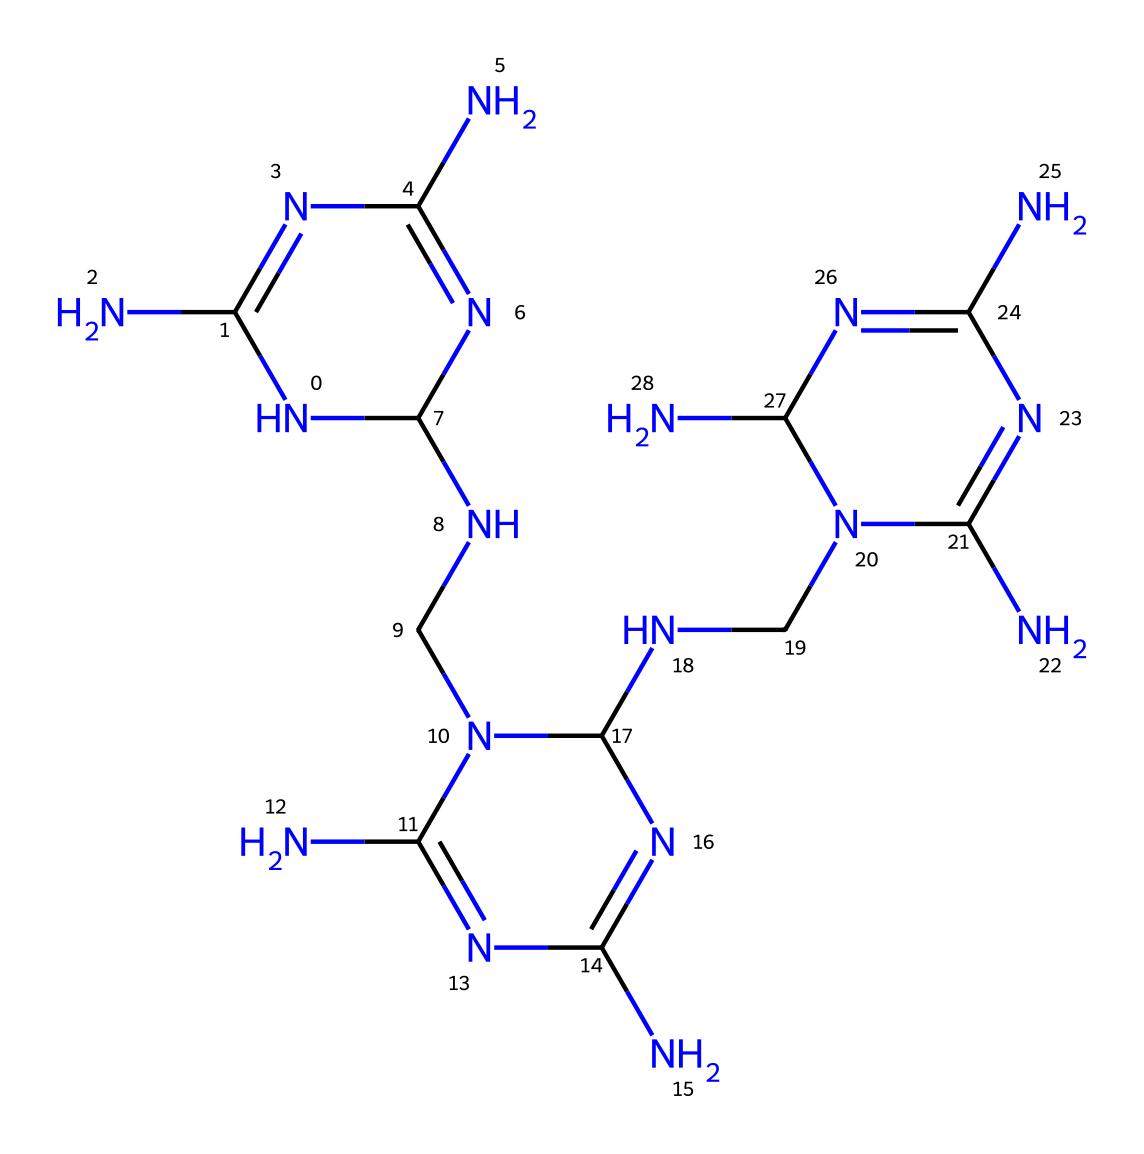What is the molecular formula of this compound? The structure shows multiple nitrogen (N) and carbon (C) atoms connected in a repeating pattern. Counting the atoms in the SMILES string, we see 12 nitrogen atoms and 6 carbon atoms. Therefore, the molecular formula is C6H18N12.
Answer: C6H18N12 How many nitrogen atoms are present in this polymer? By analyzing the SMILES representation, we can count that there are 12 nitrogen atoms represented in the structure through the "N" symbols.
Answer: 12 What type of bonding is primarily present in melamine formaldehyde? Melamine formaldehyde primarily consists of covalent bonds, which are typical in polymer structures. The numerous connections between the nitrogen and carbon atoms indicate covalent bonding throughout the polymer chain.
Answer: covalent What is the primary application of melamine formaldehyde in casinos? The primary application of melamine formaldehyde in casinos is for tabletops, as it provides durability and resistance to scratches and heat, making it practical for high-use environments.
Answer: tabletops How does the presence of nitrogen affect the thermal properties of this polymer? The nitrogen atoms in the structure contribute to the formation of strong cross-links between polymer chains, enhancing thermal stability and making the polymer more resistant to heat deformation.
Answer: enhanced thermal stability What is the significance of the repeating unit structure in this polymer? The repeating unit structure in melamine formaldehyde indicates that it forms a network polymer, which contributes to its strength and stability. The arrangement allows for an enhanced physical property compared to linear polymers.
Answer: strength and stability How does the structure influence the aesthetic properties of casino tabletops? The compact structure with numerous cross-linking provides a smooth, glossy finish that is visually appealing and can be easily colored or patterned, enhancing the esthetic value of the tabletops used in casinos.
Answer: visually appealing 